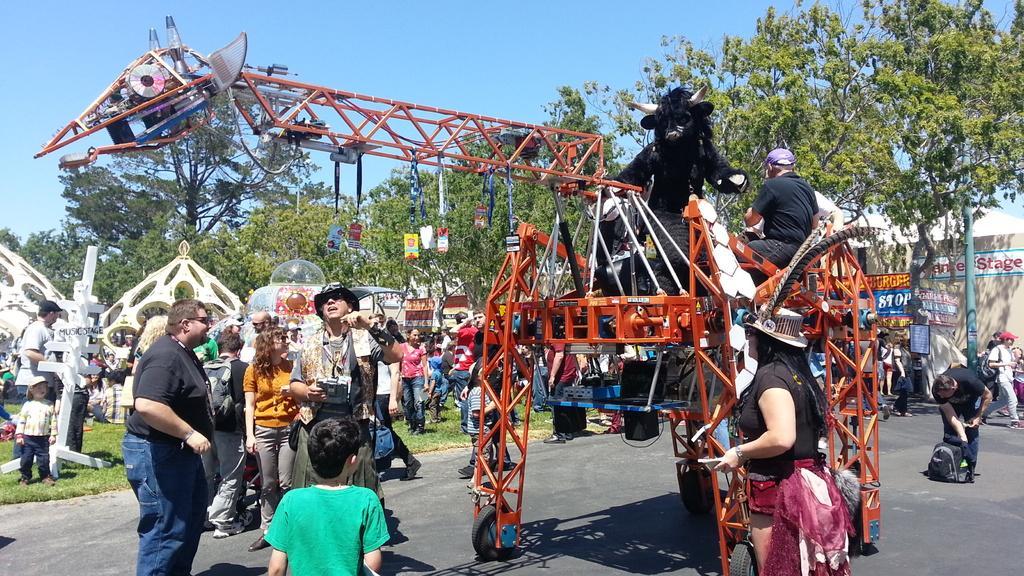How would you summarize this image in a sentence or two? This picture might be taken from outside of the city and it is sunny. In this image, on the right side, we can see a woman wearing a black color dress, we can also see another man holding a backpack. In the middle of the image, we can see a metal instrument and an animal and group of people. On the left side, we can also see group of people. In the background, we can see group people, pillars, trees, building. At the top, we can see a sky, at the bottom, we can see a road and a grass. 